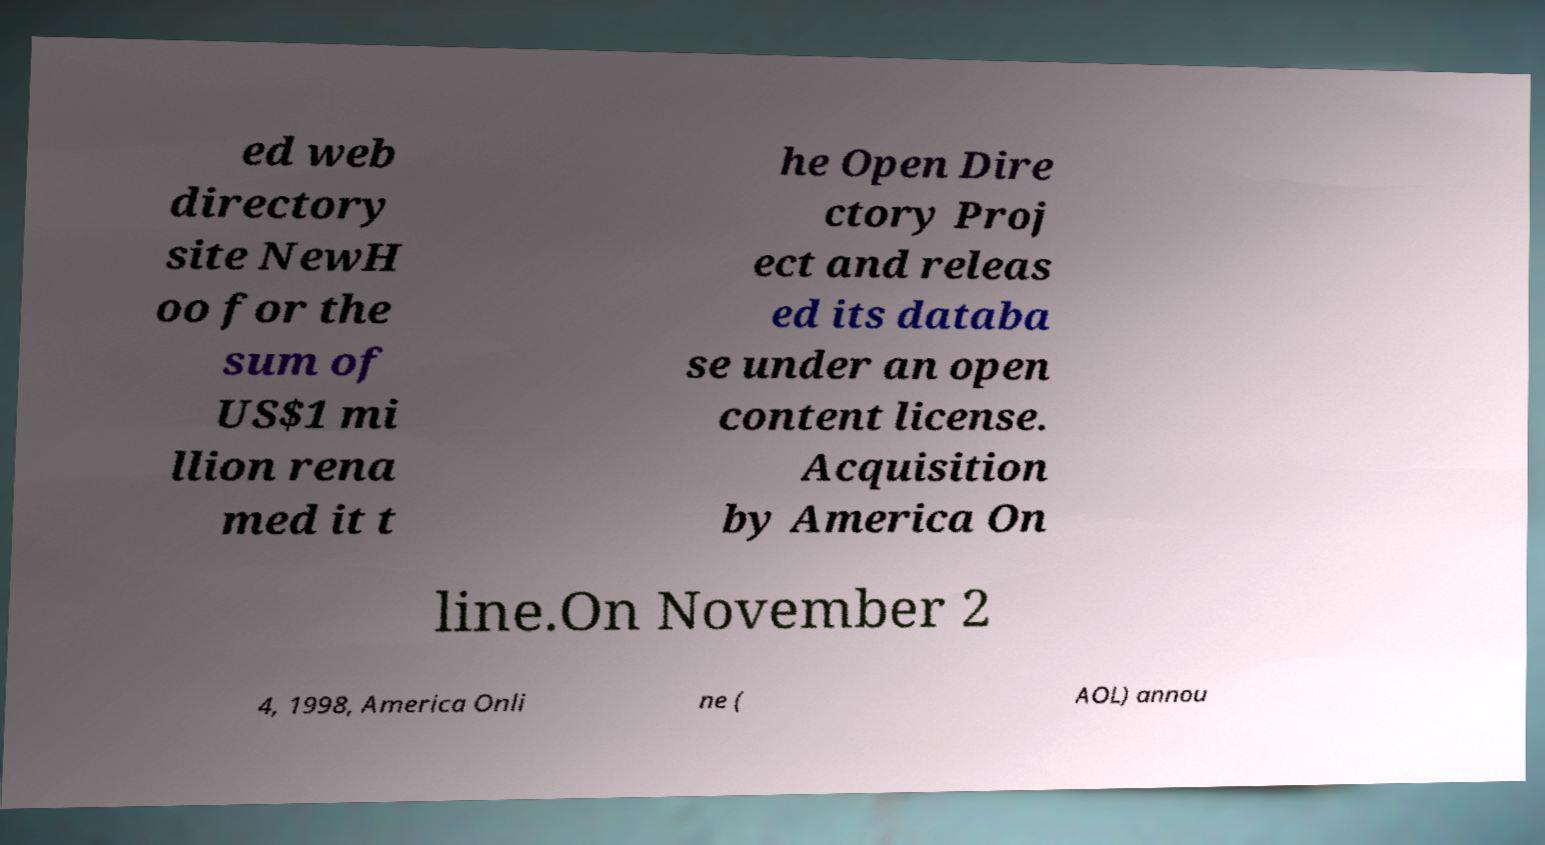Can you accurately transcribe the text from the provided image for me? ed web directory site NewH oo for the sum of US$1 mi llion rena med it t he Open Dire ctory Proj ect and releas ed its databa se under an open content license. Acquisition by America On line.On November 2 4, 1998, America Onli ne ( AOL) annou 